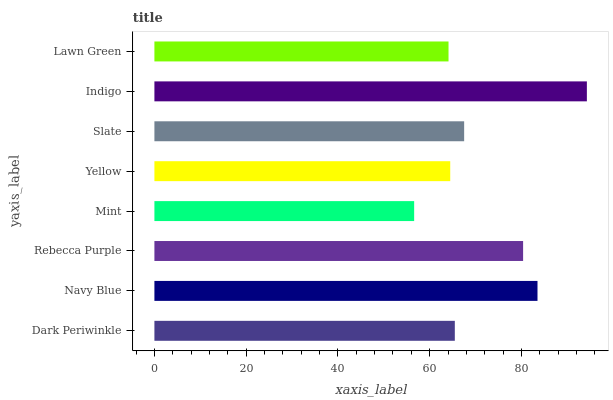Is Mint the minimum?
Answer yes or no. Yes. Is Indigo the maximum?
Answer yes or no. Yes. Is Navy Blue the minimum?
Answer yes or no. No. Is Navy Blue the maximum?
Answer yes or no. No. Is Navy Blue greater than Dark Periwinkle?
Answer yes or no. Yes. Is Dark Periwinkle less than Navy Blue?
Answer yes or no. Yes. Is Dark Periwinkle greater than Navy Blue?
Answer yes or no. No. Is Navy Blue less than Dark Periwinkle?
Answer yes or no. No. Is Slate the high median?
Answer yes or no. Yes. Is Dark Periwinkle the low median?
Answer yes or no. Yes. Is Rebecca Purple the high median?
Answer yes or no. No. Is Navy Blue the low median?
Answer yes or no. No. 